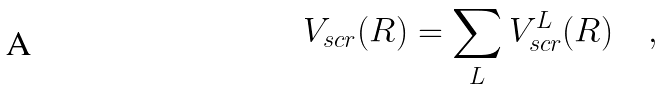<formula> <loc_0><loc_0><loc_500><loc_500>V _ { s c r } ( R ) = \sum _ { L } V ^ { L } _ { s c r } ( R ) \quad ,</formula> 